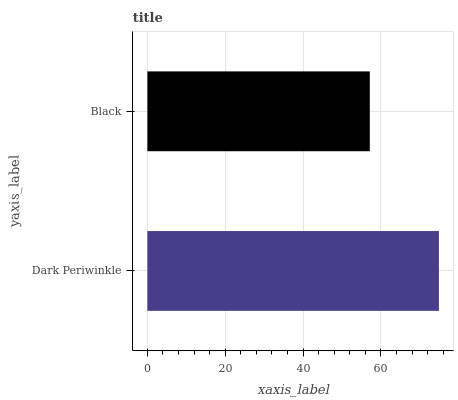Is Black the minimum?
Answer yes or no. Yes. Is Dark Periwinkle the maximum?
Answer yes or no. Yes. Is Black the maximum?
Answer yes or no. No. Is Dark Periwinkle greater than Black?
Answer yes or no. Yes. Is Black less than Dark Periwinkle?
Answer yes or no. Yes. Is Black greater than Dark Periwinkle?
Answer yes or no. No. Is Dark Periwinkle less than Black?
Answer yes or no. No. Is Dark Periwinkle the high median?
Answer yes or no. Yes. Is Black the low median?
Answer yes or no. Yes. Is Black the high median?
Answer yes or no. No. Is Dark Periwinkle the low median?
Answer yes or no. No. 